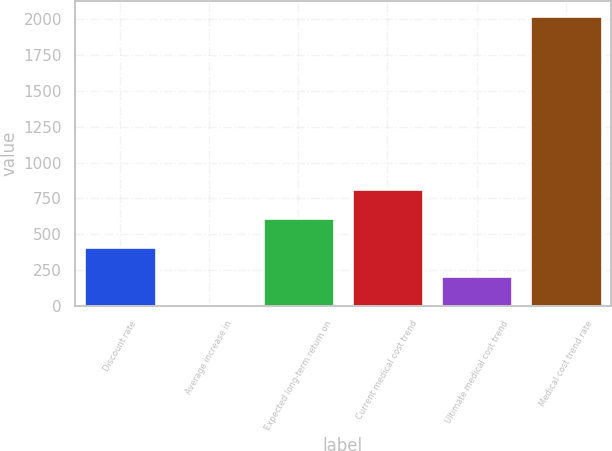Convert chart. <chart><loc_0><loc_0><loc_500><loc_500><bar_chart><fcel>Discount rate<fcel>Average increase in<fcel>Expected long-term return on<fcel>Current medical cost trend<fcel>Ultimate medical cost trend<fcel>Medical cost trend rate<nl><fcel>407.8<fcel>3.5<fcel>609.95<fcel>812.1<fcel>205.65<fcel>2025<nl></chart> 